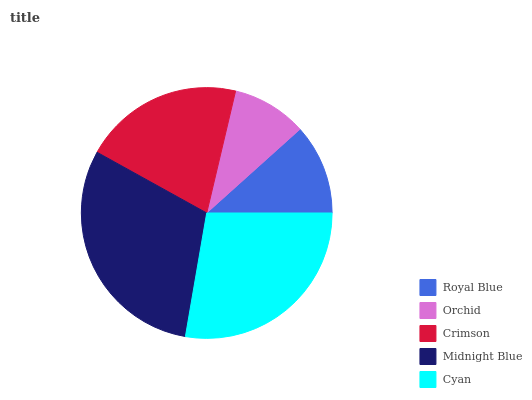Is Orchid the minimum?
Answer yes or no. Yes. Is Midnight Blue the maximum?
Answer yes or no. Yes. Is Crimson the minimum?
Answer yes or no. No. Is Crimson the maximum?
Answer yes or no. No. Is Crimson greater than Orchid?
Answer yes or no. Yes. Is Orchid less than Crimson?
Answer yes or no. Yes. Is Orchid greater than Crimson?
Answer yes or no. No. Is Crimson less than Orchid?
Answer yes or no. No. Is Crimson the high median?
Answer yes or no. Yes. Is Crimson the low median?
Answer yes or no. Yes. Is Royal Blue the high median?
Answer yes or no. No. Is Cyan the low median?
Answer yes or no. No. 